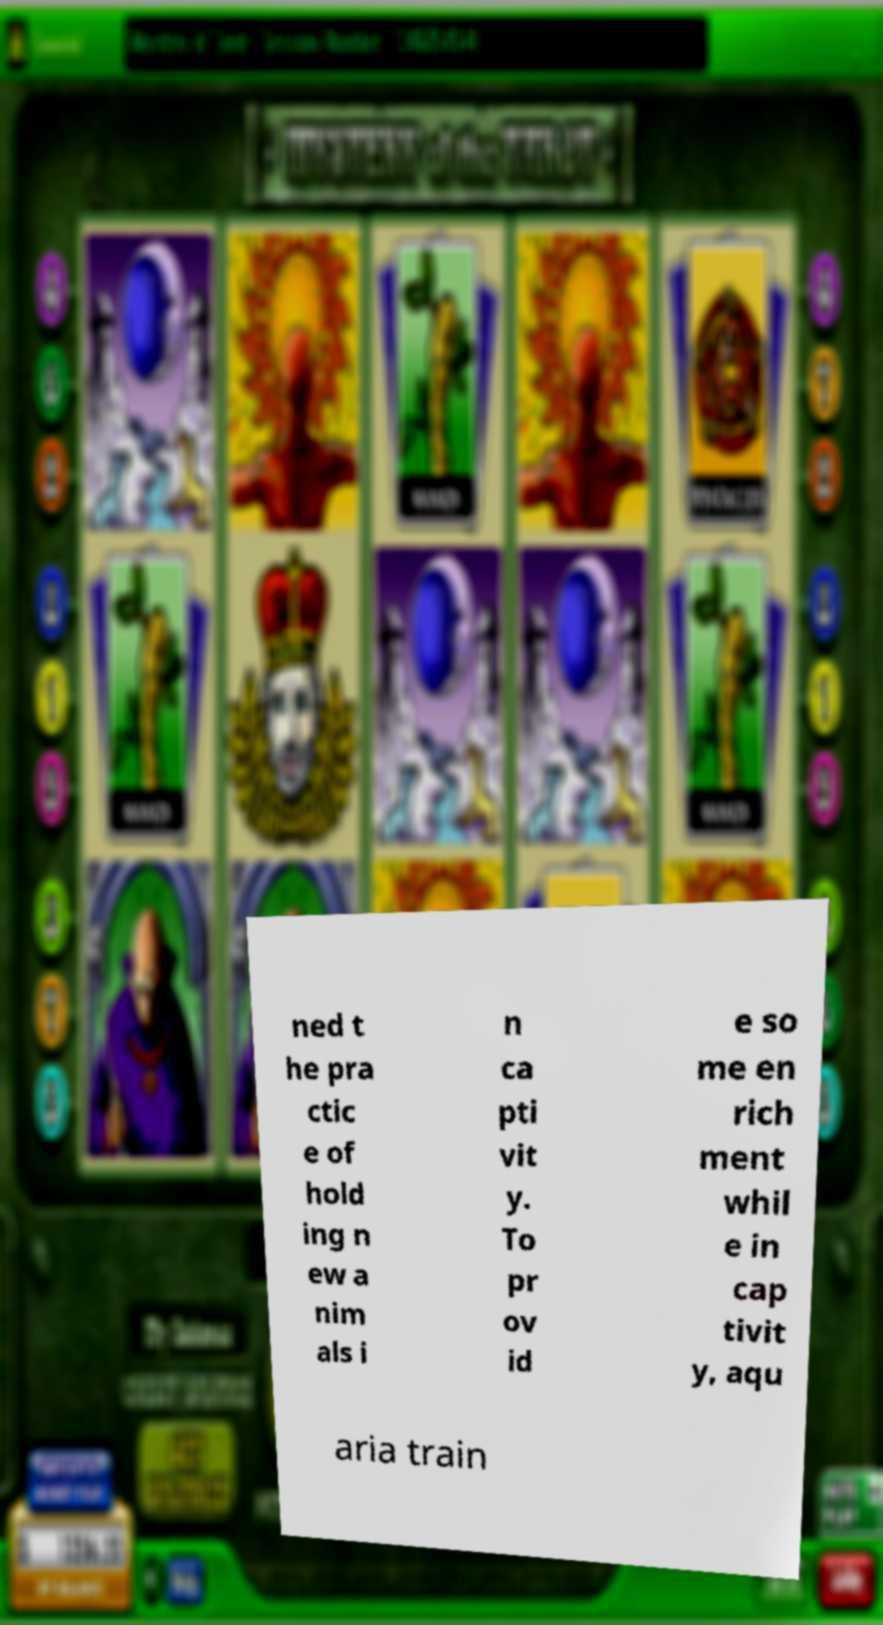Please identify and transcribe the text found in this image. ned t he pra ctic e of hold ing n ew a nim als i n ca pti vit y. To pr ov id e so me en rich ment whil e in cap tivit y, aqu aria train 